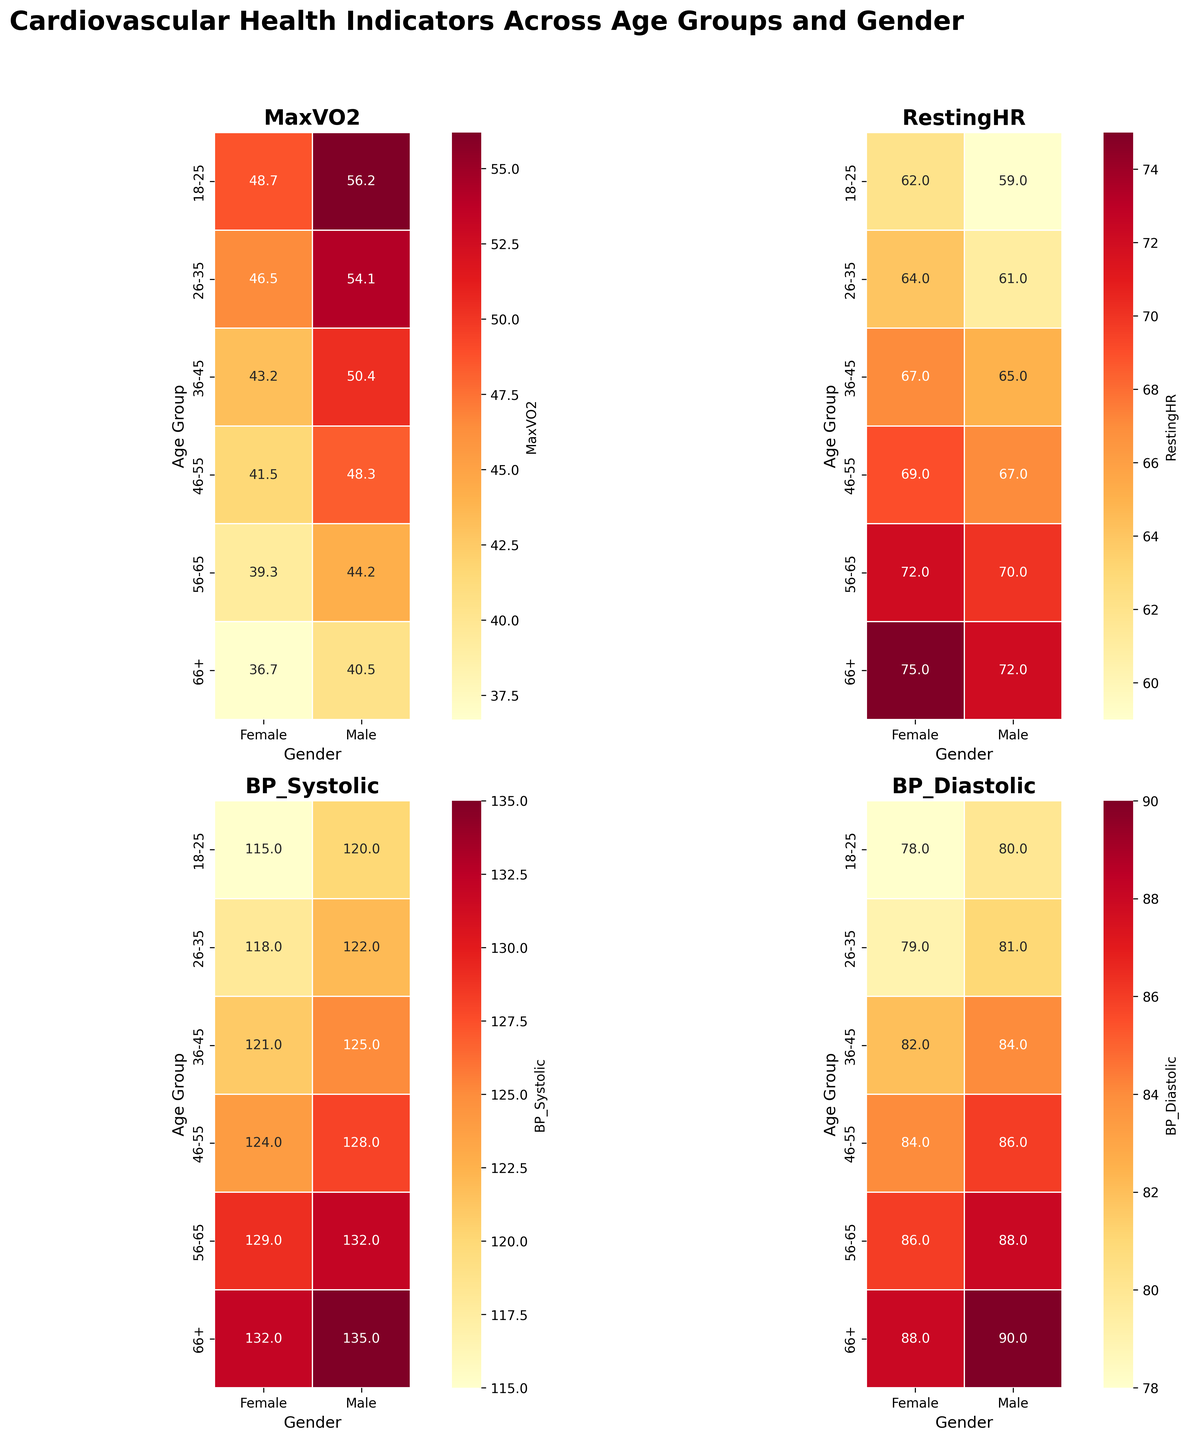What is the title of the heatmap? The title is displayed at the top center of the figure, providing an overview of what the heatmap represents.
Answer: Cardiovascular Health Indicators Across Age Groups and Gender In which age group do males have the highest Systolic Blood Pressure (BP_Systolic)? Look at the heatmap section labeled BP_Systolic, then find the highest value in the Male column.
Answer: 66+ What is the MaxVO2 value for females aged 46-55? Locate the MaxVO2 heatmap, then find the cell corresponding to the 46-55 age group under the Female column.
Answer: 41.5 How does the Resting Heart Rate (RestingHR) of males aged 56-65 compare to that of females in the same age group? Check the RestingHR heatmap for the 56-65 age group values under both Male and Female columns.
Answer: Males have a lower RestingHR (70) compared to females (72) Which gender has a lower Diastolic Blood Pressure (BP_Diastolic) in the 36-45 age group? Look at the BP_Diastolic heatmap for the 36-45 age group and compare the values for Male and Female.
Answer: Female What is the average MaxVO2 value for females across all age groups? Sum all the MaxVO2 values for females across all age groups and divide by the number of age groups (6).
Answer: (48.7 + 46.5 + 43.2 + 41.5 + 39.3 + 36.7) / 6 = 42.32 In which age group do males have the lowest MaxVO2 value, and what is that value? Check the MaxVO2 heatmap section for the lowest value under the Male column and note the corresponding age group.
Answer: 66+ with a value of 40.5 How does the BP_Systolic value of males aged 26-35 compare to the BP_Systolic value of females aged 26-35? Find the BP_Systolic heatmap section and compare the values for the 26-35 age group under both Male and Female columns.
Answer: Males have a higher BP_Systolic (122) compared to females (118) Which gender and age group combination has the highest Resting Heart Rate (RestingHR) value? Identify the RestingHR heatmap section and locate the highest value among all the cells.
Answer: Females aged 66+ with a value of 75 What is the difference in BP_Diastolic between males and females in the 46-55 age group? Subtract the BP_Diastolic value for males from that for females in the 46-55 age group.
Answer: 84 - 86 = -2 